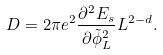Convert formula to latex. <formula><loc_0><loc_0><loc_500><loc_500>D = 2 \pi e ^ { 2 } \frac { \partial ^ { 2 } E _ { s } } { \partial \tilde { \phi } _ { L } ^ { 2 } } L ^ { 2 - d } .</formula> 